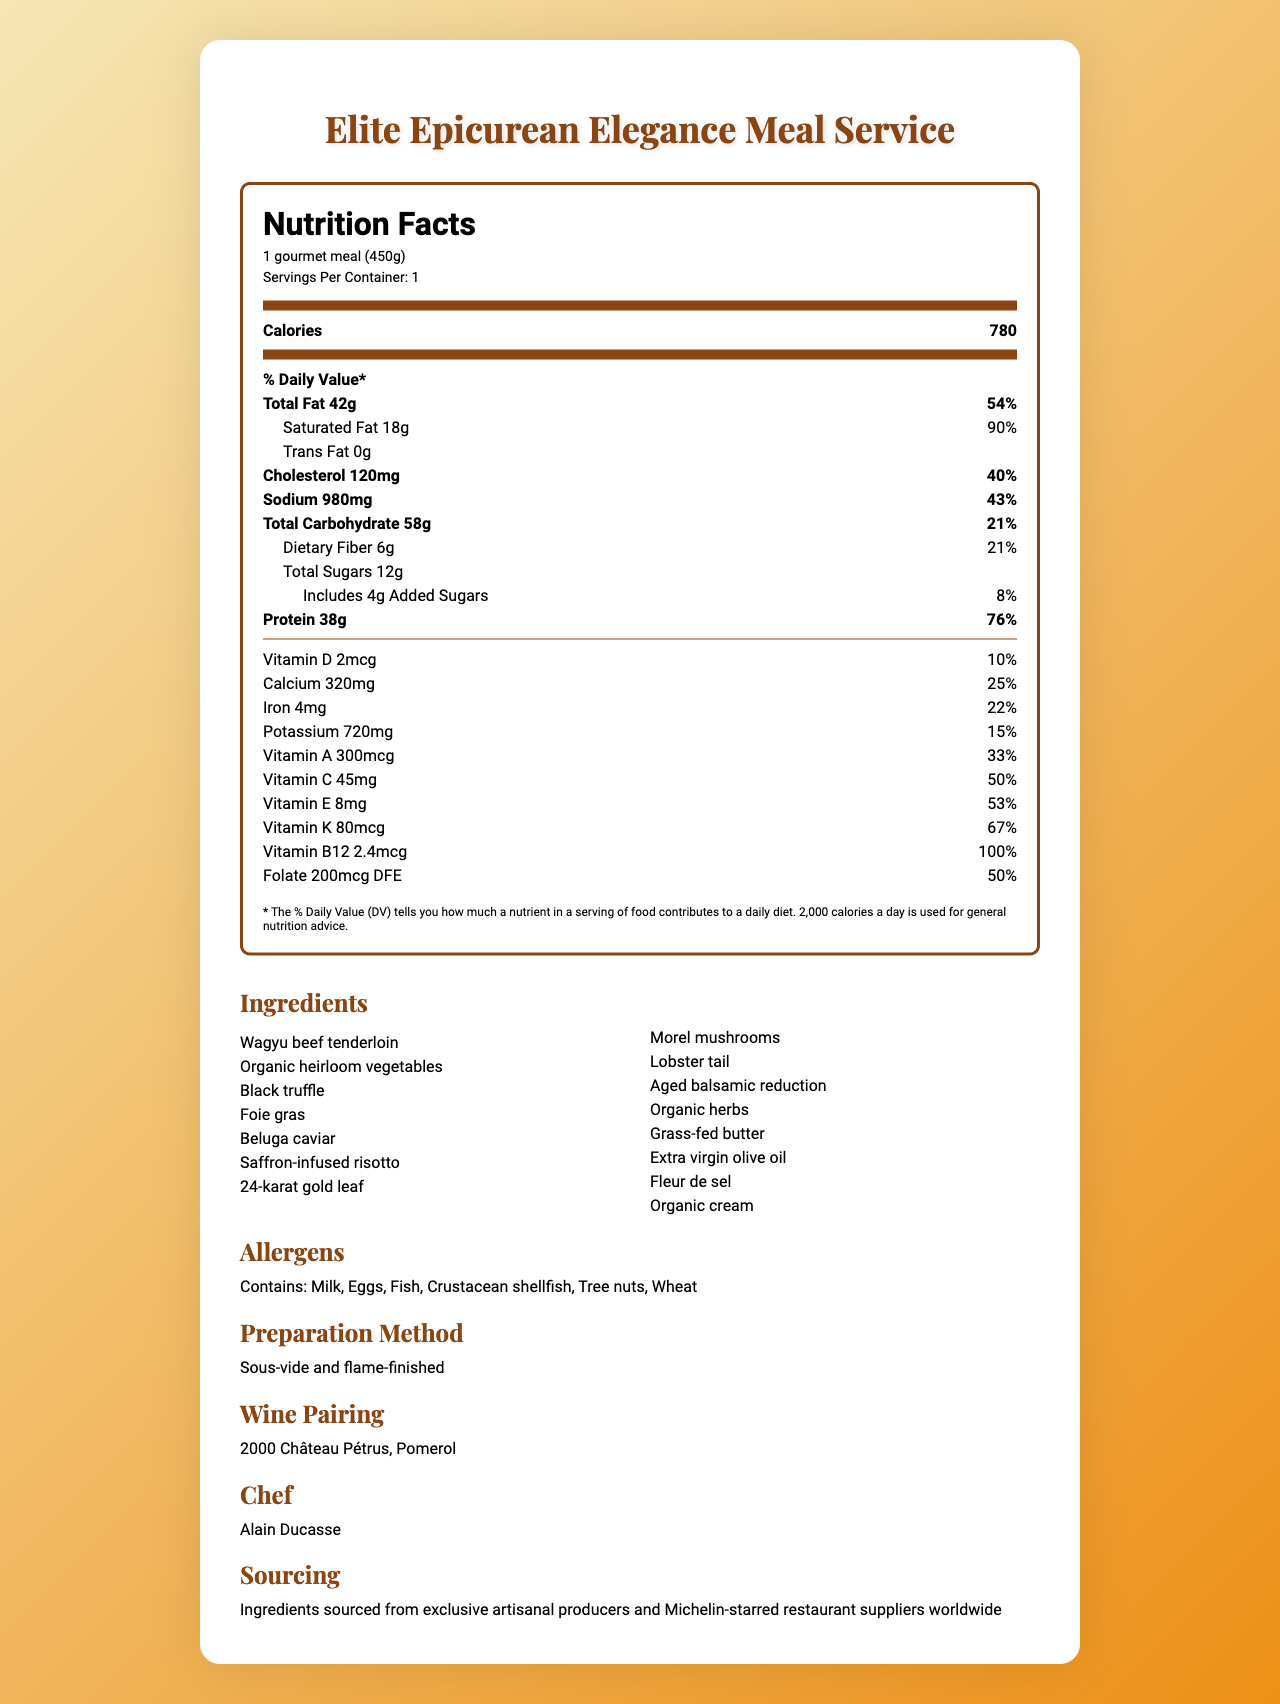what is the serving size of the Elite Epicurean Elegance Meal Service? The serving size is explicitly mentioned in the document under the serving information section.
Answer: 1 gourmet meal (450g) how many servings are in one container? The servings per container are indicated directly in the serving information section of the document.
Answer: 1 what is the total fat content in one serving? The total fat content is listed as 42 grams in the Nutrition Facts section.
Answer: 42g how much Vitamin C is in one serving, and what percentage of the daily value does this represent? The document lists Vitamin C content as 45mg and indicates it represents 50% of the daily value.
Answer: 45mg, 50% what is the main source of protein in the meal? The ingredients list includes Wagyu beef tenderloin, which is a primary source of protein.
Answer: Wagyu beef tenderloin which ingredient is not a potential allergen listed in the document? A. Milk B. Eggs C. Soy D. Fish Soy is not listed among the allergens which include Milk, Eggs, Fish, Crustacean shellfish, Tree nuts, and Wheat.
Answer: C. Soy what luxury ingredient is used in the meal? A. Black truffle B. Oysters C. White truffle D. Caviar The ingredients list includes Black truffle as one of the luxury ingredients.
Answer: A. Black truffle does the meal contain any trans fat? The trans fat content is listed as 0g in the document.
Answer: No summarize the main content of the document. The document is a comprehensive overview of the meal service, highlighting its nutritional profile, luxury ingredients, potential allergens, and preparation details by renowned chef Alain Ducasse.
Answer: The document provides detailed information about the Elite Epicurean Elegance Meal Service, including its serving size, nutritional facts, ingredients, allergens, preparation method, wine pairing, chef, and sourcing. what is the calorie content of the meal? The calorie content is clearly given in the Nutrition Facts section as 780 calories per serving.
Answer: 780 calories which vitamins are included in the nutritional information? A. Vitamin A B. Vitamin B12 C. Vitamin K D. All of the above The document lists several vitamins including Vitamin A, Vitamin B12, and Vitamin K among others in the Nutrition Facts section.
Answer: D. All of the above who is the chef responsible for preparing the meal? The chef is named in the additional information section of the document.
Answer: Alain Ducasse what method is used to prepare this exclusive meal? The preparation method is described in the additional information section.
Answer: Sous-vide and flame-finished what are the daily values for saturated fat and sodium in the meal? The daily values are listed in the Nutrition Facts section as Saturated Fat 90% and Sodium 43%.
Answer: Saturated fat: 90%, Sodium: 43% where are the ingredients for this meal sourced from? This sourcing information is mentioned in the additional information section.
Answer: Ingredients are sourced from exclusive artisanal producers and Michelin-starred restaurant suppliers worldwide what is the recommended wine pairing for the meal? The wine pairing is explicitly mentioned in the document.
Answer: 2000 Château Pétrus, Pomerol what is the daily value percentage for protein for this meal? The document states that one serving provides 76% of the daily value for protein.
Answer: 76% how much dietary fiber does the meal contain? The dietary fiber content is shown as 6 grams in the Nutrition Facts section.
Answer: 6g what is the amount of added sugars in this meal? Added sugars are listed as 4 grams in the nutritional information section.
Answer: 4g what year was the wine pairing recommended for the meal produced? The document does not provide information on the production year of the wine; it only mentions the wine pairing as "2000 Château Pétrus, Pomerol".
Answer: Cannot be determined 